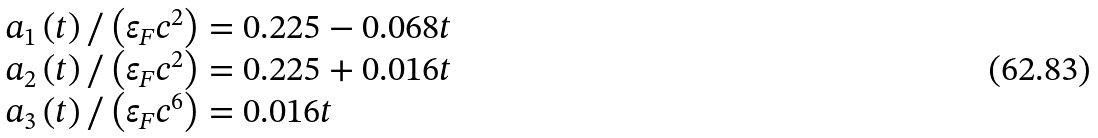Convert formula to latex. <formula><loc_0><loc_0><loc_500><loc_500>\begin{array} { l } a _ { 1 } \left ( t \right ) / \left ( \varepsilon _ { F } c ^ { 2 } \right ) = 0 . 2 2 5 - 0 . 0 6 8 t \\ a _ { 2 } \left ( t \right ) / \left ( \varepsilon _ { F } c ^ { 2 } \right ) = 0 . 2 2 5 + 0 . 0 1 6 t \\ a _ { 3 } \left ( t \right ) / \left ( \varepsilon _ { F } c ^ { 6 } \right ) = 0 . 0 1 6 t \end{array}</formula> 